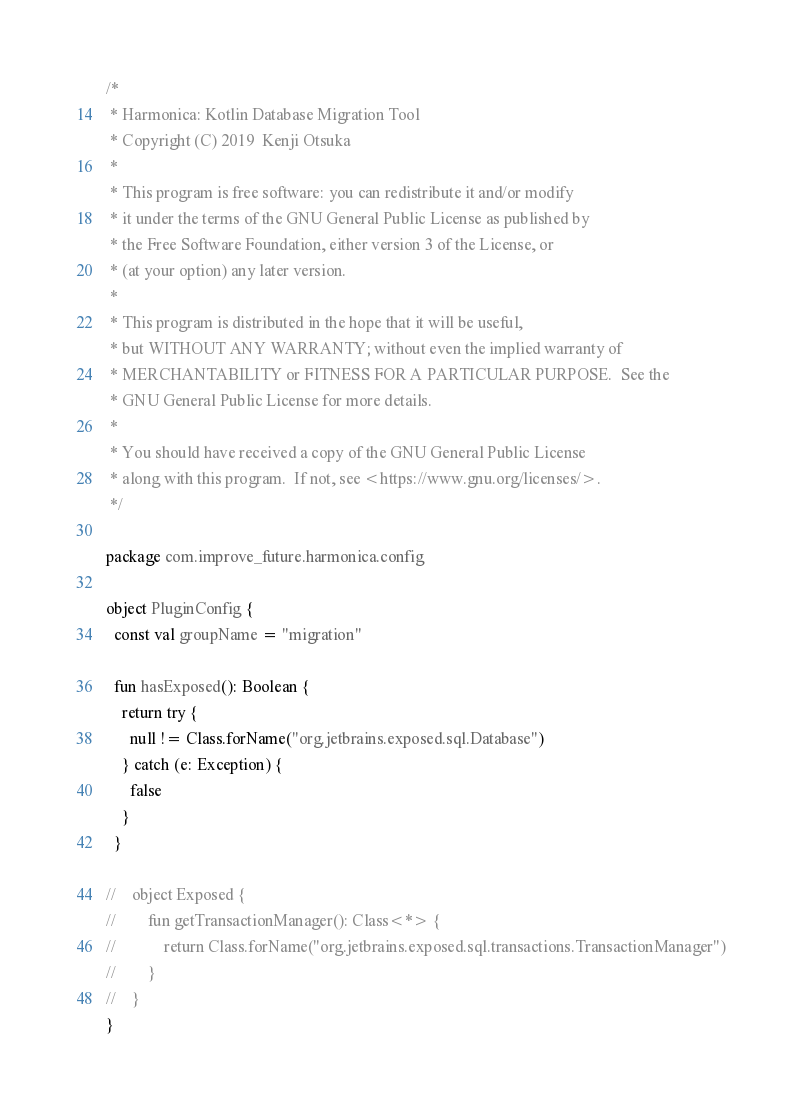Convert code to text. <code><loc_0><loc_0><loc_500><loc_500><_Kotlin_>/*
 * Harmonica: Kotlin Database Migration Tool
 * Copyright (C) 2019  Kenji Otsuka
 *
 * This program is free software: you can redistribute it and/or modify
 * it under the terms of the GNU General Public License as published by
 * the Free Software Foundation, either version 3 of the License, or
 * (at your option) any later version.
 *
 * This program is distributed in the hope that it will be useful,
 * but WITHOUT ANY WARRANTY; without even the implied warranty of
 * MERCHANTABILITY or FITNESS FOR A PARTICULAR PURPOSE.  See the
 * GNU General Public License for more details.
 *
 * You should have received a copy of the GNU General Public License
 * along with this program.  If not, see <https://www.gnu.org/licenses/>.
 */

package com.improve_future.harmonica.config

object PluginConfig {
  const val groupName = "migration"

  fun hasExposed(): Boolean {
    return try {
      null != Class.forName("org.jetbrains.exposed.sql.Database")
    } catch (e: Exception) {
      false
    }
  }

//    object Exposed {
//        fun getTransactionManager(): Class<*> {
//            return Class.forName("org.jetbrains.exposed.sql.transactions.TransactionManager")
//        }
//    }
}</code> 